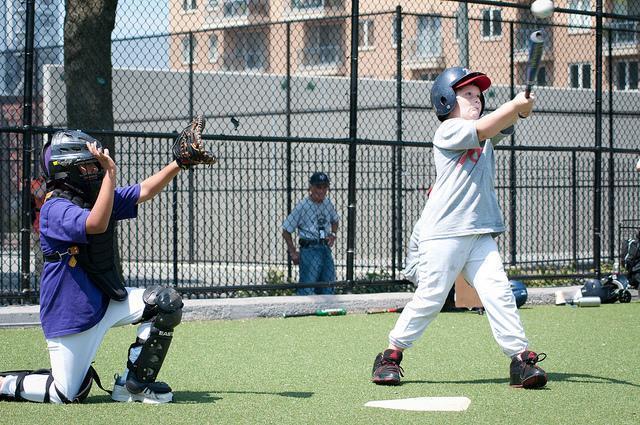How many people are in the picture?
Give a very brief answer. 3. 